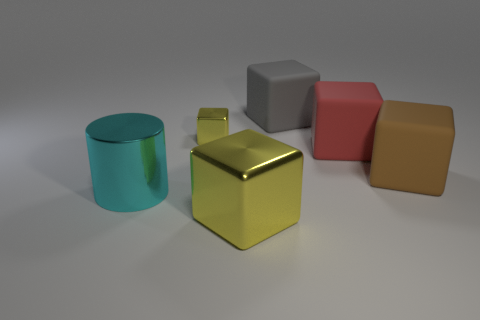Are there fewer large brown rubber blocks to the left of the big yellow metallic thing than gray metal balls? No, there are more large brown rubber blocks to the left of the big yellow metallic object than gray metal balls. Specifically, there are three large brown blocks compared to two gray metal balls. 